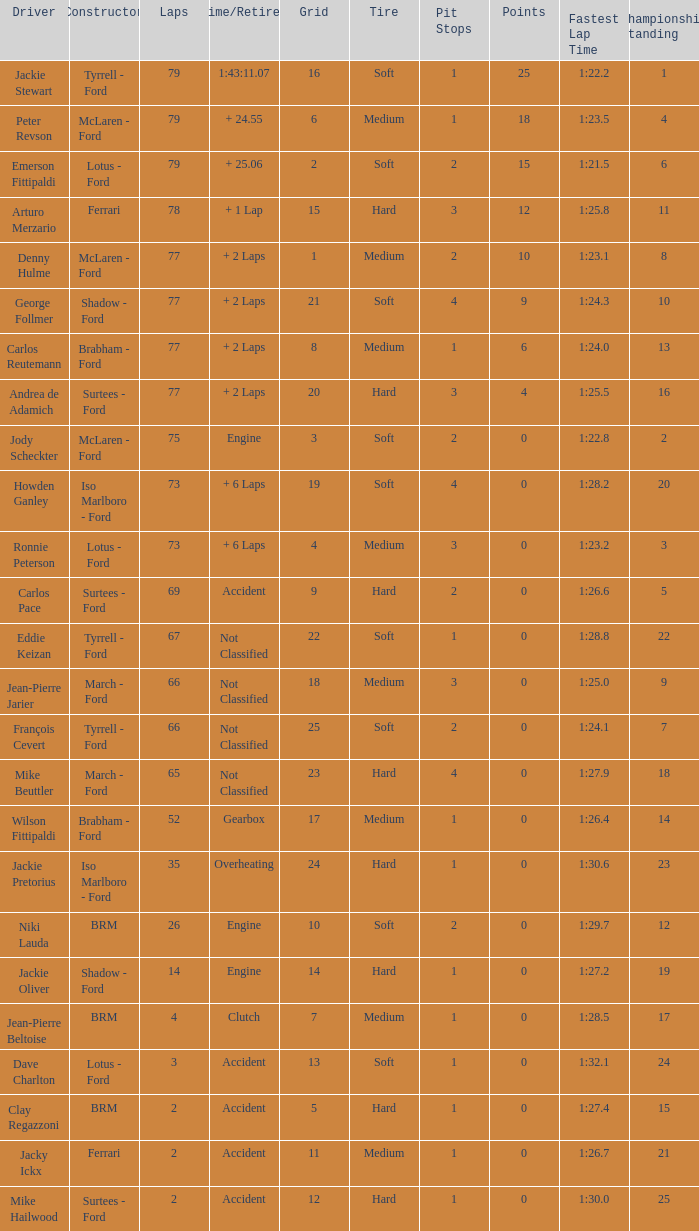How much time is required for less than 35 laps and less than 10 grids? Clutch, Accident. 